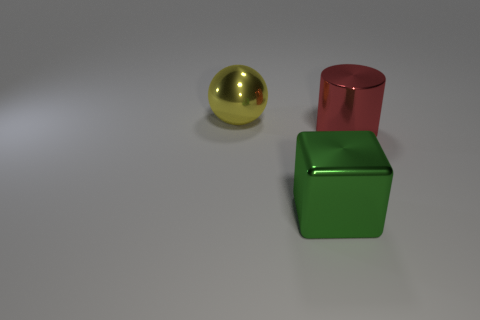Are there any other things that are the same shape as the red shiny object?
Provide a succinct answer. No. There is a large metal object on the left side of the large shiny thing in front of the large red thing; are there any metallic things that are behind it?
Make the answer very short. No. What number of red objects are the same material as the large block?
Your answer should be very brief. 1. There is a metallic thing that is to the right of the big metallic cube; is its size the same as the object that is behind the red cylinder?
Provide a succinct answer. Yes. What color is the large metal object in front of the large metal thing to the right of the big metal thing in front of the cylinder?
Offer a terse response. Green. Is the number of big shiny spheres that are in front of the big ball the same as the number of green metal things left of the cylinder?
Provide a short and direct response. No. There is a big object that is on the left side of the big green metallic block; is its shape the same as the big red object?
Offer a terse response. No. How many metal things are cyan balls or big red cylinders?
Your answer should be compact. 1. Do the green block and the red metallic thing have the same size?
Ensure brevity in your answer.  Yes. What number of things are either tiny metallic objects or large red things in front of the large shiny sphere?
Offer a terse response. 1. 